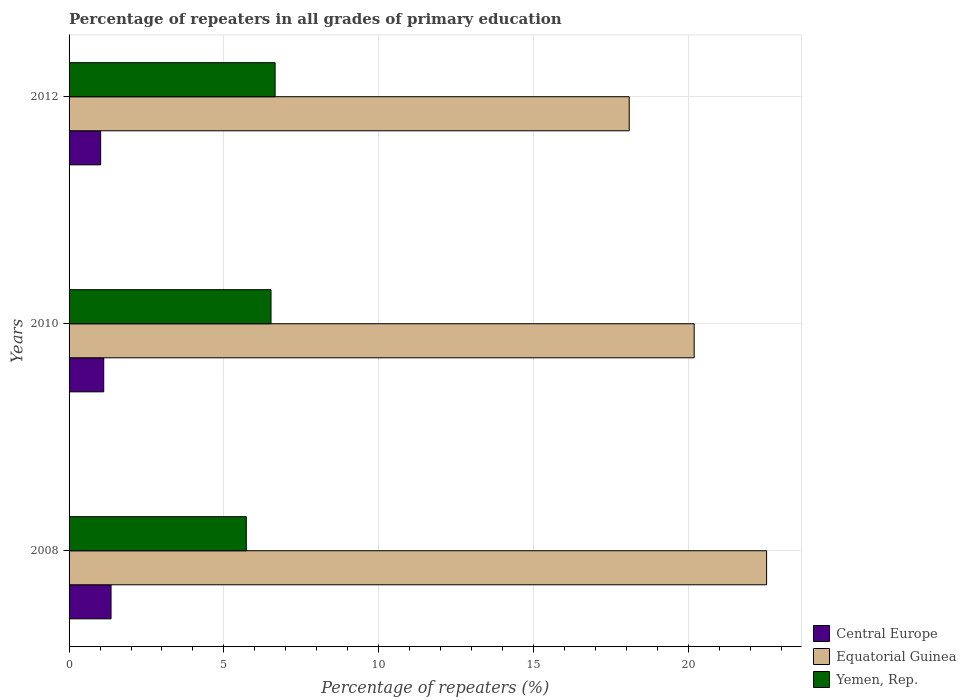How many different coloured bars are there?
Provide a short and direct response. 3. Are the number of bars per tick equal to the number of legend labels?
Ensure brevity in your answer.  Yes. Are the number of bars on each tick of the Y-axis equal?
Give a very brief answer. Yes. How many bars are there on the 1st tick from the bottom?
Keep it short and to the point. 3. In how many cases, is the number of bars for a given year not equal to the number of legend labels?
Your answer should be compact. 0. What is the percentage of repeaters in Equatorial Guinea in 2008?
Offer a terse response. 22.53. Across all years, what is the maximum percentage of repeaters in Central Europe?
Provide a short and direct response. 1.36. Across all years, what is the minimum percentage of repeaters in Yemen, Rep.?
Your response must be concise. 5.72. What is the total percentage of repeaters in Central Europe in the graph?
Give a very brief answer. 3.49. What is the difference between the percentage of repeaters in Central Europe in 2008 and that in 2010?
Your answer should be compact. 0.24. What is the difference between the percentage of repeaters in Equatorial Guinea in 2010 and the percentage of repeaters in Central Europe in 2008?
Provide a succinct answer. 18.83. What is the average percentage of repeaters in Yemen, Rep. per year?
Keep it short and to the point. 6.3. In the year 2012, what is the difference between the percentage of repeaters in Equatorial Guinea and percentage of repeaters in Yemen, Rep.?
Give a very brief answer. 11.44. In how many years, is the percentage of repeaters in Equatorial Guinea greater than 10 %?
Your answer should be compact. 3. What is the ratio of the percentage of repeaters in Yemen, Rep. in 2010 to that in 2012?
Provide a succinct answer. 0.98. Is the percentage of repeaters in Central Europe in 2008 less than that in 2012?
Your answer should be compact. No. Is the difference between the percentage of repeaters in Equatorial Guinea in 2008 and 2012 greater than the difference between the percentage of repeaters in Yemen, Rep. in 2008 and 2012?
Offer a very short reply. Yes. What is the difference between the highest and the second highest percentage of repeaters in Central Europe?
Provide a short and direct response. 0.24. What is the difference between the highest and the lowest percentage of repeaters in Central Europe?
Offer a terse response. 0.34. What does the 3rd bar from the top in 2010 represents?
Your answer should be compact. Central Europe. What does the 2nd bar from the bottom in 2008 represents?
Your answer should be very brief. Equatorial Guinea. Is it the case that in every year, the sum of the percentage of repeaters in Equatorial Guinea and percentage of repeaters in Central Europe is greater than the percentage of repeaters in Yemen, Rep.?
Your answer should be very brief. Yes. How many bars are there?
Give a very brief answer. 9. What is the difference between two consecutive major ticks on the X-axis?
Provide a succinct answer. 5. Are the values on the major ticks of X-axis written in scientific E-notation?
Your answer should be very brief. No. Does the graph contain any zero values?
Your answer should be compact. No. Does the graph contain grids?
Your answer should be compact. Yes. Where does the legend appear in the graph?
Your answer should be compact. Bottom right. How many legend labels are there?
Offer a terse response. 3. How are the legend labels stacked?
Offer a very short reply. Vertical. What is the title of the graph?
Keep it short and to the point. Percentage of repeaters in all grades of primary education. What is the label or title of the X-axis?
Your response must be concise. Percentage of repeaters (%). What is the label or title of the Y-axis?
Your response must be concise. Years. What is the Percentage of repeaters (%) of Central Europe in 2008?
Your answer should be compact. 1.36. What is the Percentage of repeaters (%) of Equatorial Guinea in 2008?
Ensure brevity in your answer.  22.53. What is the Percentage of repeaters (%) in Yemen, Rep. in 2008?
Provide a succinct answer. 5.72. What is the Percentage of repeaters (%) of Central Europe in 2010?
Your answer should be very brief. 1.12. What is the Percentage of repeaters (%) in Equatorial Guinea in 2010?
Keep it short and to the point. 20.19. What is the Percentage of repeaters (%) of Yemen, Rep. in 2010?
Provide a short and direct response. 6.52. What is the Percentage of repeaters (%) of Central Europe in 2012?
Your answer should be compact. 1.02. What is the Percentage of repeaters (%) of Equatorial Guinea in 2012?
Ensure brevity in your answer.  18.09. What is the Percentage of repeaters (%) of Yemen, Rep. in 2012?
Provide a short and direct response. 6.65. Across all years, what is the maximum Percentage of repeaters (%) of Central Europe?
Provide a succinct answer. 1.36. Across all years, what is the maximum Percentage of repeaters (%) of Equatorial Guinea?
Provide a short and direct response. 22.53. Across all years, what is the maximum Percentage of repeaters (%) of Yemen, Rep.?
Provide a short and direct response. 6.65. Across all years, what is the minimum Percentage of repeaters (%) of Central Europe?
Give a very brief answer. 1.02. Across all years, what is the minimum Percentage of repeaters (%) of Equatorial Guinea?
Your response must be concise. 18.09. Across all years, what is the minimum Percentage of repeaters (%) in Yemen, Rep.?
Your answer should be compact. 5.72. What is the total Percentage of repeaters (%) in Central Europe in the graph?
Provide a succinct answer. 3.49. What is the total Percentage of repeaters (%) of Equatorial Guinea in the graph?
Provide a succinct answer. 60.81. What is the total Percentage of repeaters (%) of Yemen, Rep. in the graph?
Provide a succinct answer. 18.9. What is the difference between the Percentage of repeaters (%) of Central Europe in 2008 and that in 2010?
Offer a very short reply. 0.24. What is the difference between the Percentage of repeaters (%) in Equatorial Guinea in 2008 and that in 2010?
Provide a succinct answer. 2.34. What is the difference between the Percentage of repeaters (%) in Yemen, Rep. in 2008 and that in 2010?
Your answer should be very brief. -0.8. What is the difference between the Percentage of repeaters (%) of Central Europe in 2008 and that in 2012?
Offer a terse response. 0.34. What is the difference between the Percentage of repeaters (%) in Equatorial Guinea in 2008 and that in 2012?
Provide a succinct answer. 4.44. What is the difference between the Percentage of repeaters (%) in Yemen, Rep. in 2008 and that in 2012?
Offer a very short reply. -0.93. What is the difference between the Percentage of repeaters (%) of Central Europe in 2010 and that in 2012?
Offer a terse response. 0.1. What is the difference between the Percentage of repeaters (%) of Equatorial Guinea in 2010 and that in 2012?
Provide a succinct answer. 2.1. What is the difference between the Percentage of repeaters (%) of Yemen, Rep. in 2010 and that in 2012?
Offer a terse response. -0.13. What is the difference between the Percentage of repeaters (%) in Central Europe in 2008 and the Percentage of repeaters (%) in Equatorial Guinea in 2010?
Ensure brevity in your answer.  -18.83. What is the difference between the Percentage of repeaters (%) of Central Europe in 2008 and the Percentage of repeaters (%) of Yemen, Rep. in 2010?
Offer a very short reply. -5.17. What is the difference between the Percentage of repeaters (%) of Equatorial Guinea in 2008 and the Percentage of repeaters (%) of Yemen, Rep. in 2010?
Your response must be concise. 16.01. What is the difference between the Percentage of repeaters (%) of Central Europe in 2008 and the Percentage of repeaters (%) of Equatorial Guinea in 2012?
Ensure brevity in your answer.  -16.74. What is the difference between the Percentage of repeaters (%) of Central Europe in 2008 and the Percentage of repeaters (%) of Yemen, Rep. in 2012?
Provide a succinct answer. -5.3. What is the difference between the Percentage of repeaters (%) of Equatorial Guinea in 2008 and the Percentage of repeaters (%) of Yemen, Rep. in 2012?
Provide a short and direct response. 15.87. What is the difference between the Percentage of repeaters (%) of Central Europe in 2010 and the Percentage of repeaters (%) of Equatorial Guinea in 2012?
Your response must be concise. -16.97. What is the difference between the Percentage of repeaters (%) in Central Europe in 2010 and the Percentage of repeaters (%) in Yemen, Rep. in 2012?
Keep it short and to the point. -5.54. What is the difference between the Percentage of repeaters (%) in Equatorial Guinea in 2010 and the Percentage of repeaters (%) in Yemen, Rep. in 2012?
Provide a short and direct response. 13.53. What is the average Percentage of repeaters (%) in Central Europe per year?
Your answer should be very brief. 1.16. What is the average Percentage of repeaters (%) in Equatorial Guinea per year?
Provide a short and direct response. 20.27. What is the average Percentage of repeaters (%) of Yemen, Rep. per year?
Keep it short and to the point. 6.3. In the year 2008, what is the difference between the Percentage of repeaters (%) in Central Europe and Percentage of repeaters (%) in Equatorial Guinea?
Your answer should be compact. -21.17. In the year 2008, what is the difference between the Percentage of repeaters (%) in Central Europe and Percentage of repeaters (%) in Yemen, Rep.?
Provide a succinct answer. -4.37. In the year 2008, what is the difference between the Percentage of repeaters (%) in Equatorial Guinea and Percentage of repeaters (%) in Yemen, Rep.?
Provide a succinct answer. 16.8. In the year 2010, what is the difference between the Percentage of repeaters (%) in Central Europe and Percentage of repeaters (%) in Equatorial Guinea?
Give a very brief answer. -19.07. In the year 2010, what is the difference between the Percentage of repeaters (%) in Central Europe and Percentage of repeaters (%) in Yemen, Rep.?
Provide a succinct answer. -5.4. In the year 2010, what is the difference between the Percentage of repeaters (%) of Equatorial Guinea and Percentage of repeaters (%) of Yemen, Rep.?
Your answer should be compact. 13.67. In the year 2012, what is the difference between the Percentage of repeaters (%) of Central Europe and Percentage of repeaters (%) of Equatorial Guinea?
Offer a very short reply. -17.07. In the year 2012, what is the difference between the Percentage of repeaters (%) of Central Europe and Percentage of repeaters (%) of Yemen, Rep.?
Provide a short and direct response. -5.63. In the year 2012, what is the difference between the Percentage of repeaters (%) in Equatorial Guinea and Percentage of repeaters (%) in Yemen, Rep.?
Offer a very short reply. 11.44. What is the ratio of the Percentage of repeaters (%) in Central Europe in 2008 to that in 2010?
Give a very brief answer. 1.21. What is the ratio of the Percentage of repeaters (%) in Equatorial Guinea in 2008 to that in 2010?
Keep it short and to the point. 1.12. What is the ratio of the Percentage of repeaters (%) in Yemen, Rep. in 2008 to that in 2010?
Give a very brief answer. 0.88. What is the ratio of the Percentage of repeaters (%) of Central Europe in 2008 to that in 2012?
Provide a succinct answer. 1.33. What is the ratio of the Percentage of repeaters (%) in Equatorial Guinea in 2008 to that in 2012?
Offer a terse response. 1.25. What is the ratio of the Percentage of repeaters (%) of Yemen, Rep. in 2008 to that in 2012?
Give a very brief answer. 0.86. What is the ratio of the Percentage of repeaters (%) of Central Europe in 2010 to that in 2012?
Give a very brief answer. 1.1. What is the ratio of the Percentage of repeaters (%) in Equatorial Guinea in 2010 to that in 2012?
Provide a succinct answer. 1.12. What is the ratio of the Percentage of repeaters (%) of Yemen, Rep. in 2010 to that in 2012?
Give a very brief answer. 0.98. What is the difference between the highest and the second highest Percentage of repeaters (%) of Central Europe?
Offer a terse response. 0.24. What is the difference between the highest and the second highest Percentage of repeaters (%) in Equatorial Guinea?
Offer a very short reply. 2.34. What is the difference between the highest and the second highest Percentage of repeaters (%) of Yemen, Rep.?
Your answer should be very brief. 0.13. What is the difference between the highest and the lowest Percentage of repeaters (%) of Central Europe?
Ensure brevity in your answer.  0.34. What is the difference between the highest and the lowest Percentage of repeaters (%) of Equatorial Guinea?
Give a very brief answer. 4.44. What is the difference between the highest and the lowest Percentage of repeaters (%) of Yemen, Rep.?
Offer a very short reply. 0.93. 